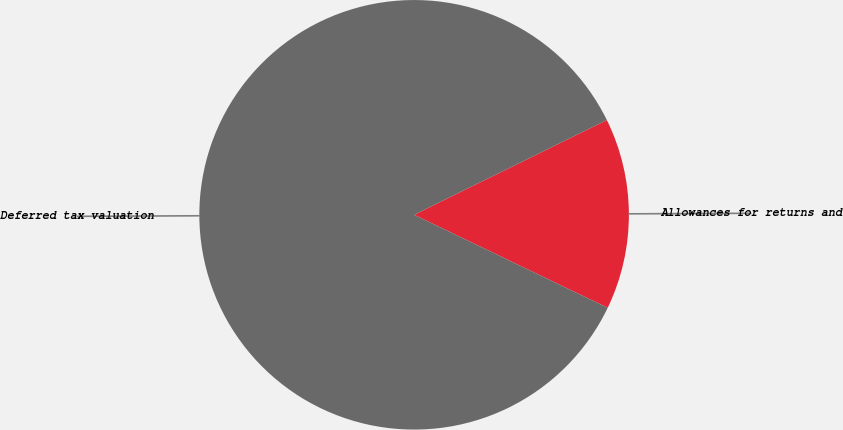Convert chart to OTSL. <chart><loc_0><loc_0><loc_500><loc_500><pie_chart><fcel>Allowances for returns and<fcel>Deferred tax valuation<nl><fcel>14.4%<fcel>85.6%<nl></chart> 